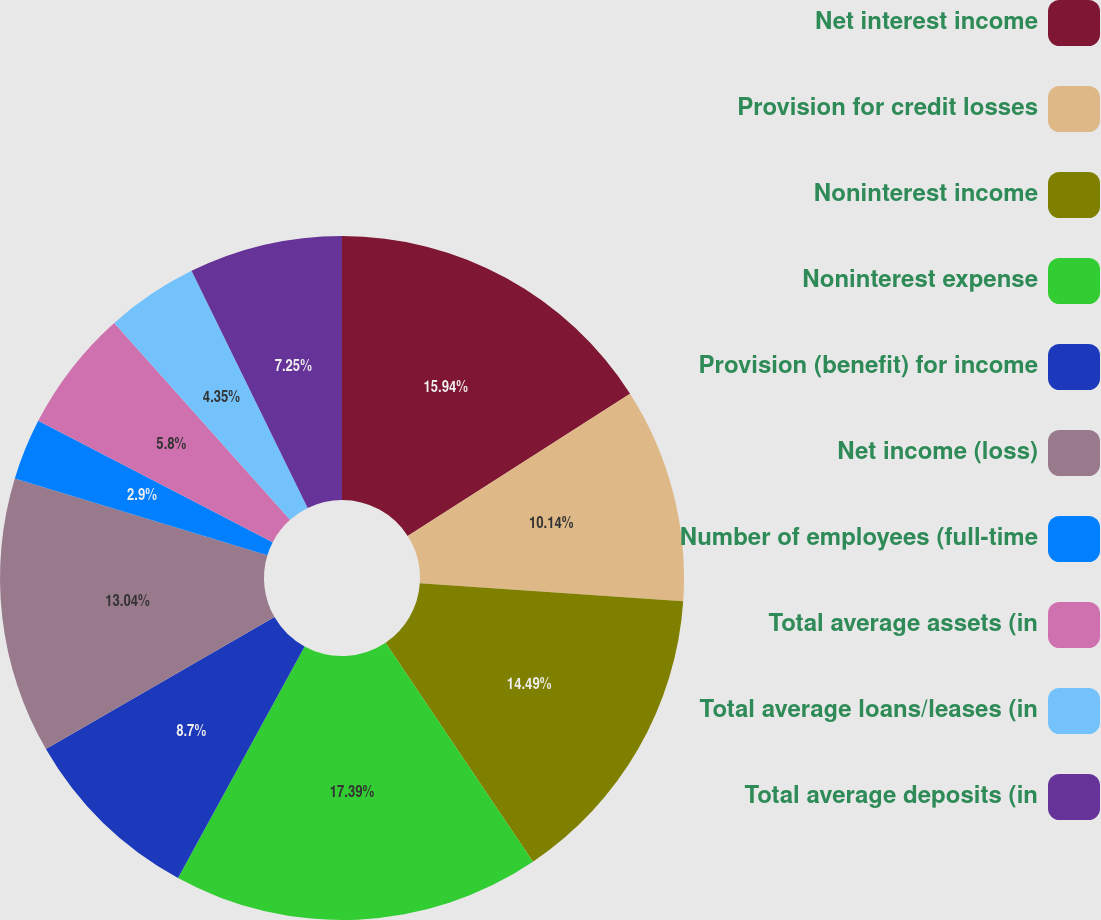Convert chart. <chart><loc_0><loc_0><loc_500><loc_500><pie_chart><fcel>Net interest income<fcel>Provision for credit losses<fcel>Noninterest income<fcel>Noninterest expense<fcel>Provision (benefit) for income<fcel>Net income (loss)<fcel>Number of employees (full-time<fcel>Total average assets (in<fcel>Total average loans/leases (in<fcel>Total average deposits (in<nl><fcel>15.94%<fcel>10.14%<fcel>14.49%<fcel>17.39%<fcel>8.7%<fcel>13.04%<fcel>2.9%<fcel>5.8%<fcel>4.35%<fcel>7.25%<nl></chart> 